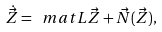<formula> <loc_0><loc_0><loc_500><loc_500>\dot { \vec { Z } } = \ m a t { L } \vec { Z } + \vec { N } ( \vec { Z } ) ,</formula> 